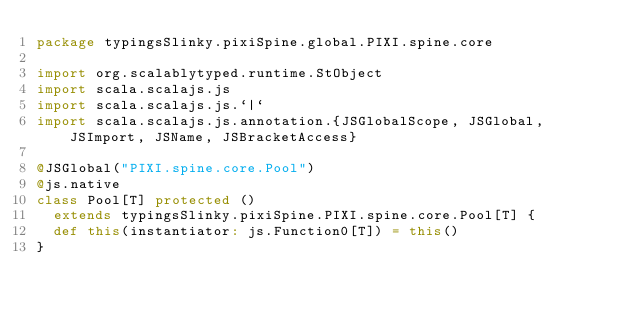Convert code to text. <code><loc_0><loc_0><loc_500><loc_500><_Scala_>package typingsSlinky.pixiSpine.global.PIXI.spine.core

import org.scalablytyped.runtime.StObject
import scala.scalajs.js
import scala.scalajs.js.`|`
import scala.scalajs.js.annotation.{JSGlobalScope, JSGlobal, JSImport, JSName, JSBracketAccess}

@JSGlobal("PIXI.spine.core.Pool")
@js.native
class Pool[T] protected ()
  extends typingsSlinky.pixiSpine.PIXI.spine.core.Pool[T] {
  def this(instantiator: js.Function0[T]) = this()
}
</code> 